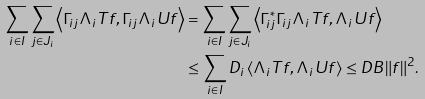<formula> <loc_0><loc_0><loc_500><loc_500>\sum _ { i \in I } \sum _ { j \in J _ { i } } \left \langle \Gamma _ { i j } \Lambda _ { i } T f , \Gamma _ { i j } \Lambda _ { i } U f \right \rangle & = \sum _ { i \in I } \sum _ { j \in J _ { i } } \left \langle \Gamma ^ { * } _ { i j } \Gamma _ { i j } \Lambda _ { i } T f , \Lambda _ { i } U f \right \rangle \\ & \leq \sum _ { i \in I } D _ { i } \left \langle \Lambda _ { i } T f , \Lambda _ { i } U f \right \rangle \leq D B \| f \| ^ { 2 } .</formula> 